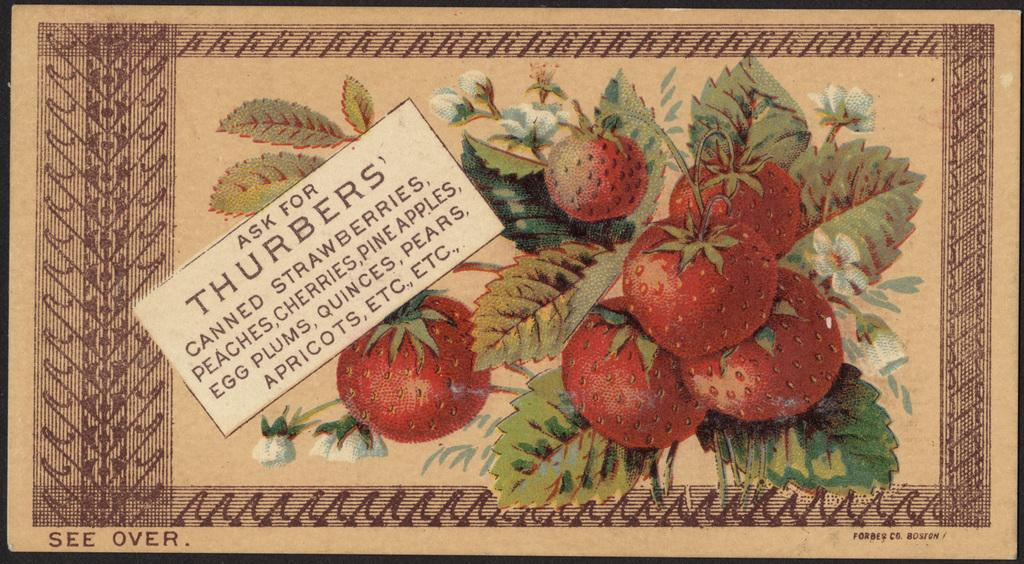What is featured in the picture? There is a poster in the picture. What is depicted on the poster? The poster contains many tomatoes and leaves. What type of throne is shown in the picture? There is no throne present in the picture; it only features a poster with tomatoes and leaves. What medical advice can be found on the poster? There is no doctor or medical advice present on the poster; it only contains images of tomatoes and leaves. 